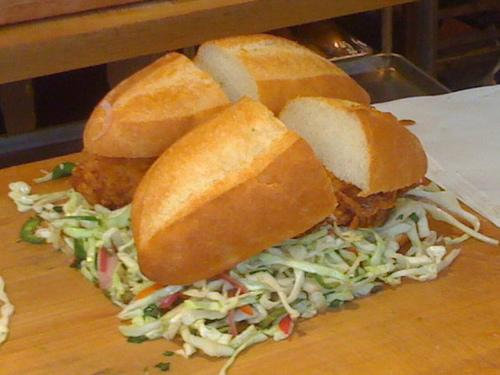How many people is this food for most likely? two 